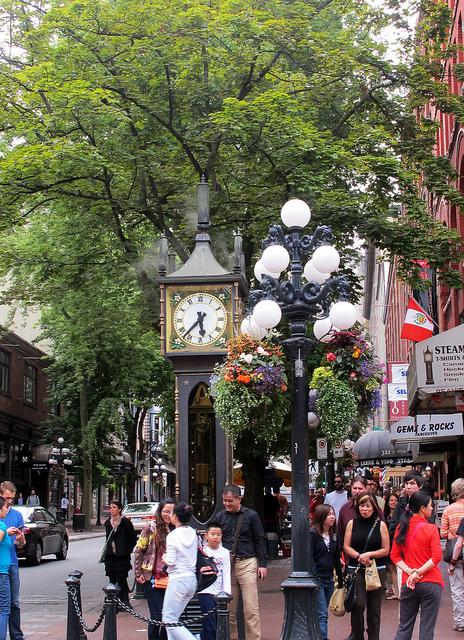What is coming out of the clock? steam 